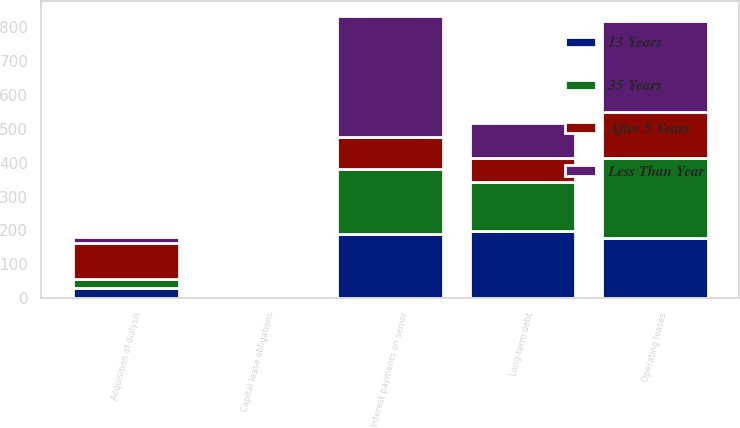Convert chart to OTSL. <chart><loc_0><loc_0><loc_500><loc_500><stacked_bar_chart><ecel><fcel>Long-term debt<fcel>Interest payments on senior<fcel>Capital lease obligations<fcel>Operating leases<fcel>Acquisition of dialysis<nl><fcel>After 5 Years<fcel>71<fcel>95<fcel>1<fcel>137<fcel>105<nl><fcel>35 Years<fcel>143<fcel>190<fcel>3<fcel>236<fcel>27<nl><fcel>13 Years<fcel>199<fcel>190<fcel>1<fcel>178<fcel>30<nl><fcel>Less Than Year<fcel>105<fcel>360<fcel>2<fcel>267<fcel>17<nl></chart> 